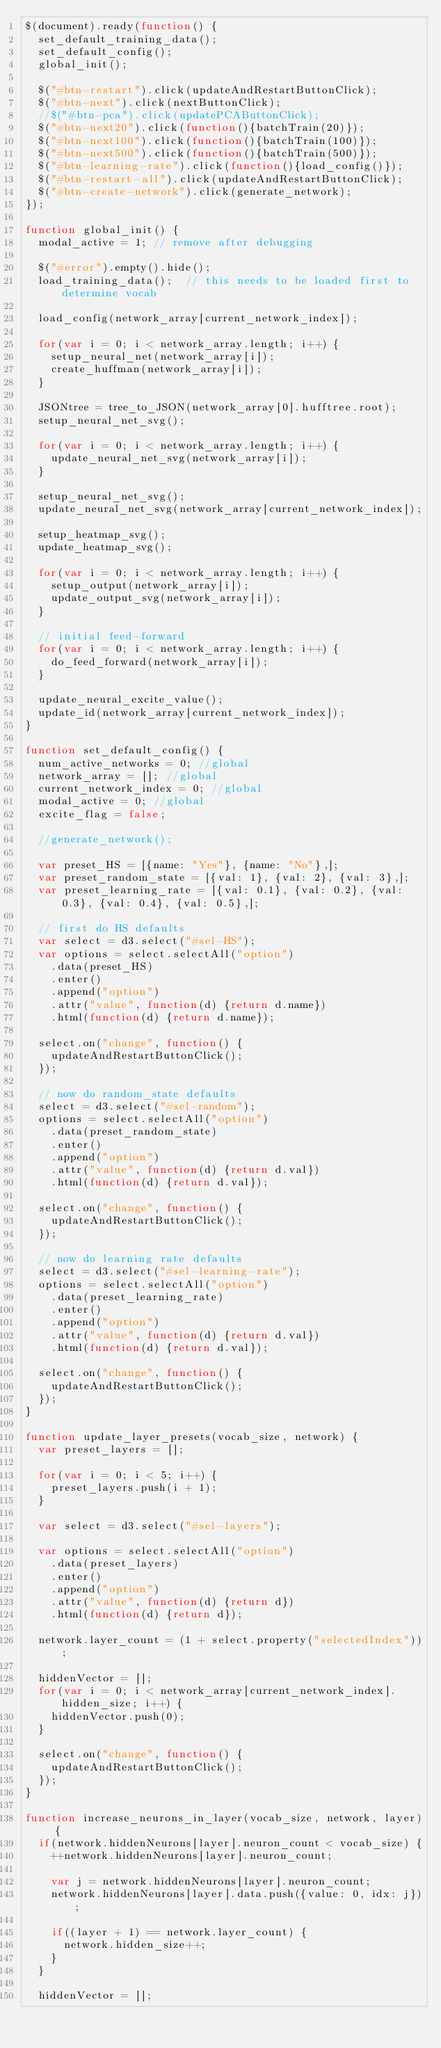Convert code to text. <code><loc_0><loc_0><loc_500><loc_500><_JavaScript_>$(document).ready(function() {
  set_default_training_data();
  set_default_config();
  global_init();

  $("#btn-restart").click(updateAndRestartButtonClick);
  $("#btn-next").click(nextButtonClick);
  //$("#btn-pca").click(updatePCAButtonClick);
  $("#btn-next20").click(function(){batchTrain(20)});
  $("#btn-next100").click(function(){batchTrain(100)});
  $("#btn-next500").click(function(){batchTrain(500)});
  $("#btn-learning-rate").click(function(){load_config()});
  $("#btn-restart-all").click(updateAndRestartButtonClick);
  $("#btn-create-network").click(generate_network);
});

function global_init() {
  modal_active = 1; // remove after debugging

  $("#error").empty().hide();
  load_training_data();  // this needs to be loaded first to determine vocab

  load_config(network_array[current_network_index]);

  for(var i = 0; i < network_array.length; i++) {
    setup_neural_net(network_array[i]);  
    create_huffman(network_array[i]);
  }
    
  JSONtree = tree_to_JSON(network_array[0].hufftree.root);
  setup_neural_net_svg();

  for(var i = 0; i < network_array.length; i++) {
    update_neural_net_svg(network_array[i]);
  }

  setup_neural_net_svg();
  update_neural_net_svg(network_array[current_network_index]);
  
  setup_heatmap_svg();
  update_heatmap_svg();

  for(var i = 0; i < network_array.length; i++) {
    setup_output(network_array[i]);
    update_output_svg(network_array[i]);
  }

  // initial feed-forward
  for(var i = 0; i < network_array.length; i++) {
    do_feed_forward(network_array[i]);
  }

  update_neural_excite_value();
  update_id(network_array[current_network_index]);
}

function set_default_config() {
  num_active_networks = 0; //global
  network_array = []; //global
  current_network_index = 0; //global
  modal_active = 0; //global
  excite_flag = false;

  //generate_network();

  var preset_HS = [{name: "Yes"}, {name: "No"},];
  var preset_random_state = [{val: 1}, {val: 2}, {val: 3},];
  var preset_learning_rate = [{val: 0.1}, {val: 0.2}, {val: 0.3}, {val: 0.4}, {val: 0.5},];

  // first do HS defaults
  var select = d3.select("#sel-HS");
  var options = select.selectAll("option")
    .data(preset_HS)
    .enter()
    .append("option")
    .attr("value", function(d) {return d.name})
    .html(function(d) {return d.name});
  
  select.on("change", function() {
    updateAndRestartButtonClick();
  });

  // now do random_state defaults
  select = d3.select("#sel-random");
  options = select.selectAll("option")
    .data(preset_random_state)
    .enter()
    .append("option")
    .attr("value", function(d) {return d.val})
    .html(function(d) {return d.val});

  select.on("change", function() {
    updateAndRestartButtonClick();
  });

  // now do learning rate defaults
  select = d3.select("#sel-learning-rate");
  options = select.selectAll("option")
    .data(preset_learning_rate)
    .enter()
    .append("option")
    .attr("value", function(d) {return d.val})
    .html(function(d) {return d.val});

  select.on("change", function() {
    updateAndRestartButtonClick();
  }); 
}

function update_layer_presets(vocab_size, network) {
  var preset_layers = [];
  
  for(var i = 0; i < 5; i++) {
    preset_layers.push(i + 1);
  }

  var select = d3.select("#sel-layers");

  var options = select.selectAll("option")
    .data(preset_layers)
    .enter()
    .append("option")
    .attr("value", function(d) {return d})
    .html(function(d) {return d});

  network.layer_count = (1 + select.property("selectedIndex"));

  hiddenVector = [];
  for(var i = 0; i < network_array[current_network_index].hidden_size; i++) {
    hiddenVector.push(0);
  }

  select.on("change", function() {
    updateAndRestartButtonClick();
  });
}

function increase_neurons_in_layer(vocab_size, network, layer) {
  if(network.hiddenNeurons[layer].neuron_count < vocab_size) {
    ++network.hiddenNeurons[layer].neuron_count;

    var j = network.hiddenNeurons[layer].neuron_count;
    network.hiddenNeurons[layer].data.push({value: 0, idx: j});

    if((layer + 1) == network.layer_count) {
      network.hidden_size++;
    }
  }

  hiddenVector = [];</code> 